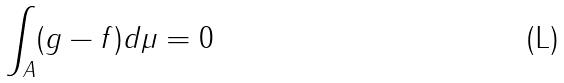Convert formula to latex. <formula><loc_0><loc_0><loc_500><loc_500>\int _ { A } ( g - f ) d \mu = 0</formula> 